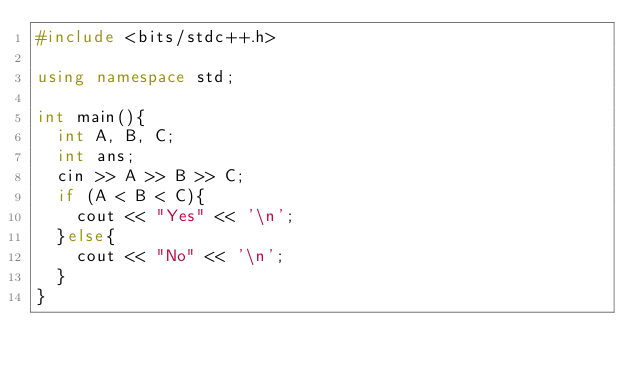<code> <loc_0><loc_0><loc_500><loc_500><_C++_>#include <bits/stdc++.h>

using namespace std;

int main(){
  int A, B, C;
  int ans;
  cin >> A >> B >> C;
  if (A < B < C){
    cout << "Yes" << '\n';
  }else{
    cout << "No" << '\n';
  }
}</code> 